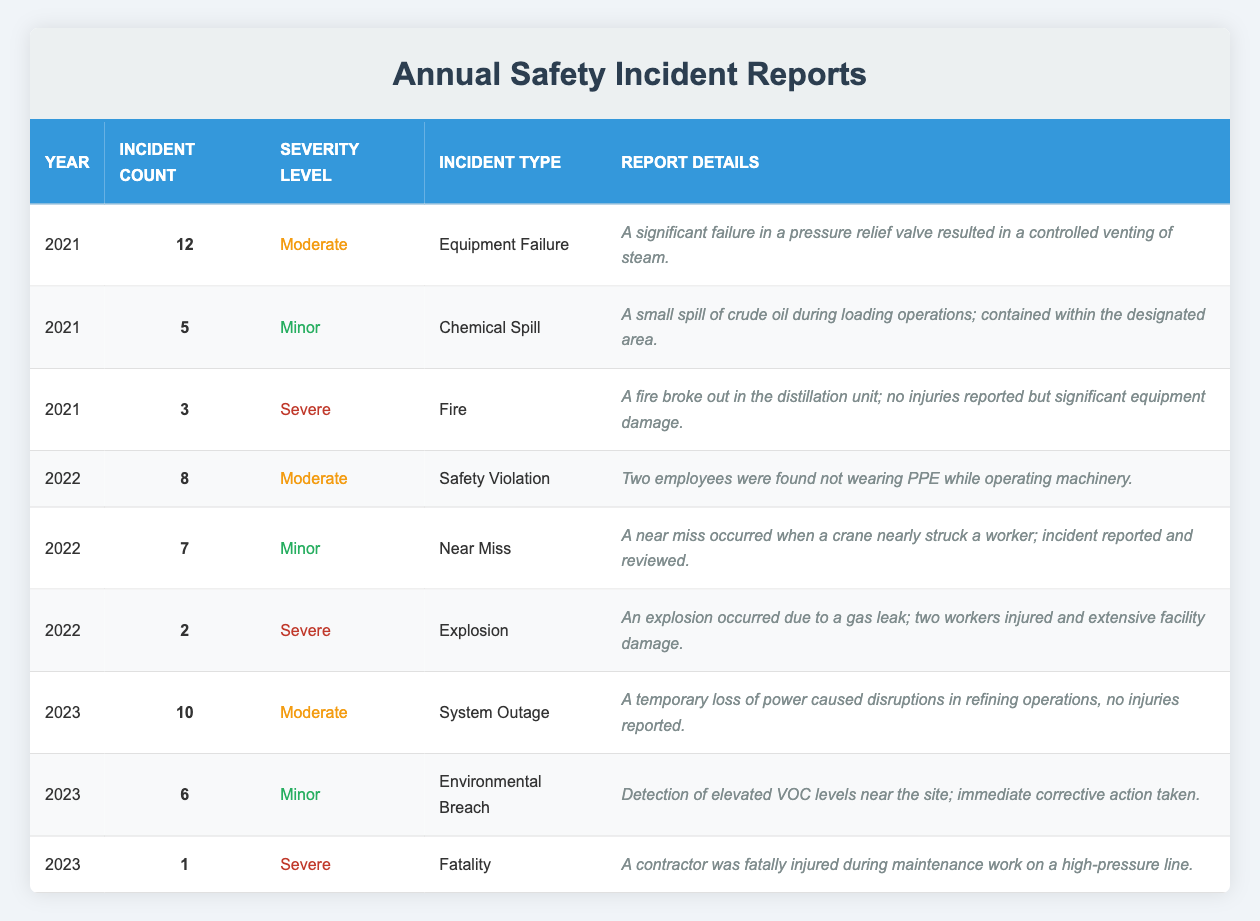What was the total incident count in 2021? In 2021, there were 12 incidents from Equipment Failure, 5 from Chemical Spill, and 3 from Fire. Adding these counts together gives 12 + 5 + 3 = 20.
Answer: 20 What is the severity level of the incident reported in 2022 with the incident type "Explosion"? The row for the year 2022 and the incident type "Explosion" indicates a severity level of "Severe".
Answer: Severe How many incidents occurred in 2023 in total? In 2023, there were 10 incidents from System Outage, 6 from Environmental Breach, and 1 from Fatality. Adding these gives 10 + 6 + 1 = 17.
Answer: 17 Did any incidents in 2022 result in fatalities? Reviewing the incident reports from 2022, the details indicate that there were no fatalities reported in that year, as the report of "Explosion" indicates injuries but no fatalities.
Answer: No What is the difference in incident counts between 2021 and 2022? In 2021, there were 20 incidents, and in 2022 there were 17 incidents. The difference is calculated as 20 - 17 = 3.
Answer: 3 Which year had the highest count of incidents categorized as "Severe"? Looking at the data, in 2021 there were 3 severe incidents, and in 2022 there were 2 severe incidents while in 2023 there was 1 severe incident. The highest count of 3 severe incidents occurred in 2021.
Answer: 2021 What types of incidents were reported in 2023? The types of incidents reported in 2023 include System Outage, Environmental Breach, and Fatality. These are detailed in the table entries for that year.
Answer: System Outage, Environmental Breach, Fatality How many incidents did not result in injuries across all years reported? From the table, the incidents without reported injuries are the Minor incidents (5 in 2021, 7 in 2022, 6 in 2023 - total 18) and the Moderate incidents (12 in 2021, 8 in 2022, 10 in 2023 - total 30). Severe incidents that mention no injuries are the Fire in 2021 (noted as no injuries). Summing these gives a total of 18 (Minor) + 30 (Moderate) + 2 (from Fire) = 50.
Answer: 50 What was the report detail for the "Fire" incident in 2021? The report for the "Fire" incident in 2021 states, "A fire broke out in the distillation unit; no injuries reported but significant equipment damage."
Answer: A fire broke out in the distillation unit; no injuries reported but significant equipment damage 